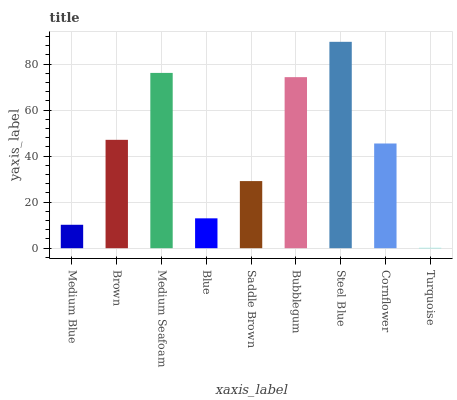Is Turquoise the minimum?
Answer yes or no. Yes. Is Steel Blue the maximum?
Answer yes or no. Yes. Is Brown the minimum?
Answer yes or no. No. Is Brown the maximum?
Answer yes or no. No. Is Brown greater than Medium Blue?
Answer yes or no. Yes. Is Medium Blue less than Brown?
Answer yes or no. Yes. Is Medium Blue greater than Brown?
Answer yes or no. No. Is Brown less than Medium Blue?
Answer yes or no. No. Is Cornflower the high median?
Answer yes or no. Yes. Is Cornflower the low median?
Answer yes or no. Yes. Is Bubblegum the high median?
Answer yes or no. No. Is Medium Seafoam the low median?
Answer yes or no. No. 